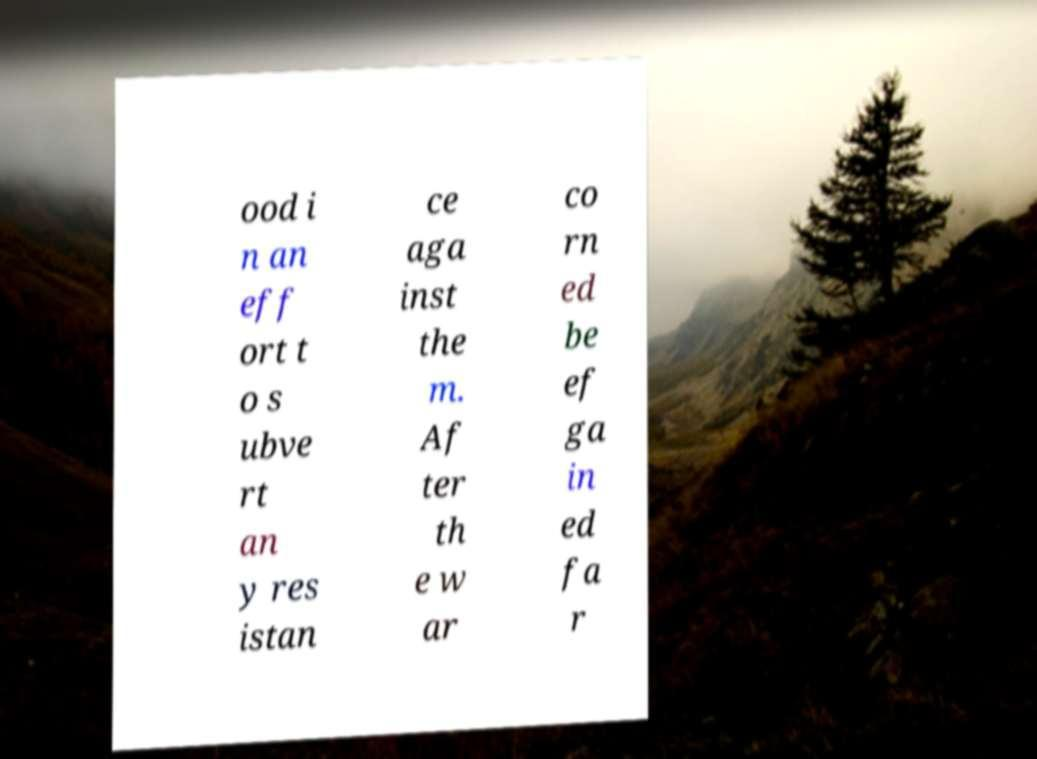There's text embedded in this image that I need extracted. Can you transcribe it verbatim? ood i n an eff ort t o s ubve rt an y res istan ce aga inst the m. Af ter th e w ar co rn ed be ef ga in ed fa r 